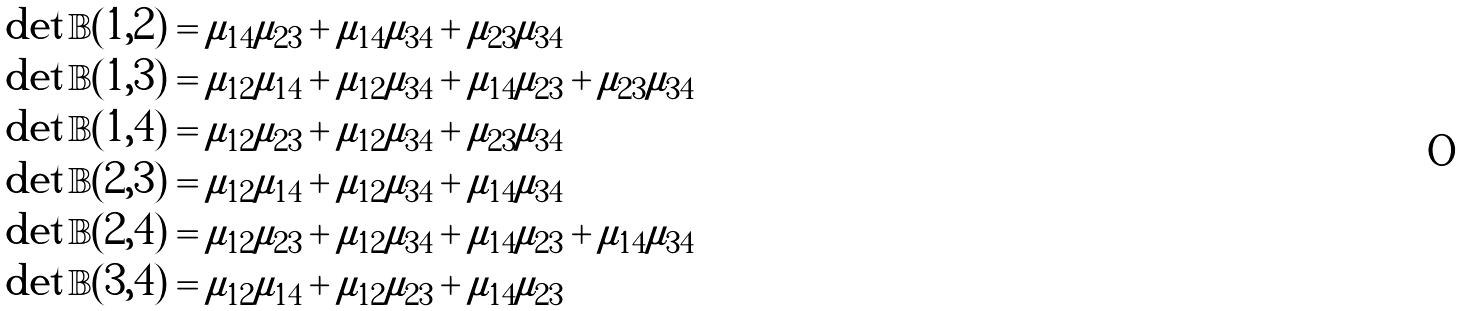<formula> <loc_0><loc_0><loc_500><loc_500>\det \mathbb { B } ( 1 , 2 ) & = \mu _ { 1 4 } \mu _ { 2 3 } + \mu _ { 1 4 } \mu _ { 3 4 } + \mu _ { 2 3 } \mu _ { 3 4 } \\ \det \mathbb { B } ( 1 , 3 ) & = \mu _ { 1 2 } \mu _ { 1 4 } + \mu _ { 1 2 } \mu _ { 3 4 } + \mu _ { 1 4 } \mu _ { 2 3 } + \mu _ { 2 3 } \mu _ { 3 4 } \\ \det \mathbb { B } ( 1 , 4 ) & = \mu _ { 1 2 } \mu _ { 2 3 } + \mu _ { 1 2 } \mu _ { 3 4 } + \mu _ { 2 3 } \mu _ { 3 4 } \\ \det \mathbb { B } ( 2 , 3 ) & = \mu _ { 1 2 } \mu _ { 1 4 } + \mu _ { 1 2 } \mu _ { 3 4 } + \mu _ { 1 4 } \mu _ { 3 4 } \\ \det \mathbb { B } ( 2 , 4 ) & = \mu _ { 1 2 } \mu _ { 2 3 } + \mu _ { 1 2 } \mu _ { 3 4 } + \mu _ { 1 4 } \mu _ { 2 3 } + \mu _ { 1 4 } \mu _ { 3 4 } \\ \det \mathbb { B } ( 3 , 4 ) & = \mu _ { 1 2 } \mu _ { 1 4 } + \mu _ { 1 2 } \mu _ { 2 3 } + \mu _ { 1 4 } \mu _ { 2 3 }</formula> 